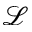Convert formula to latex. <formula><loc_0><loc_0><loc_500><loc_500>\mathcal { L }</formula> 